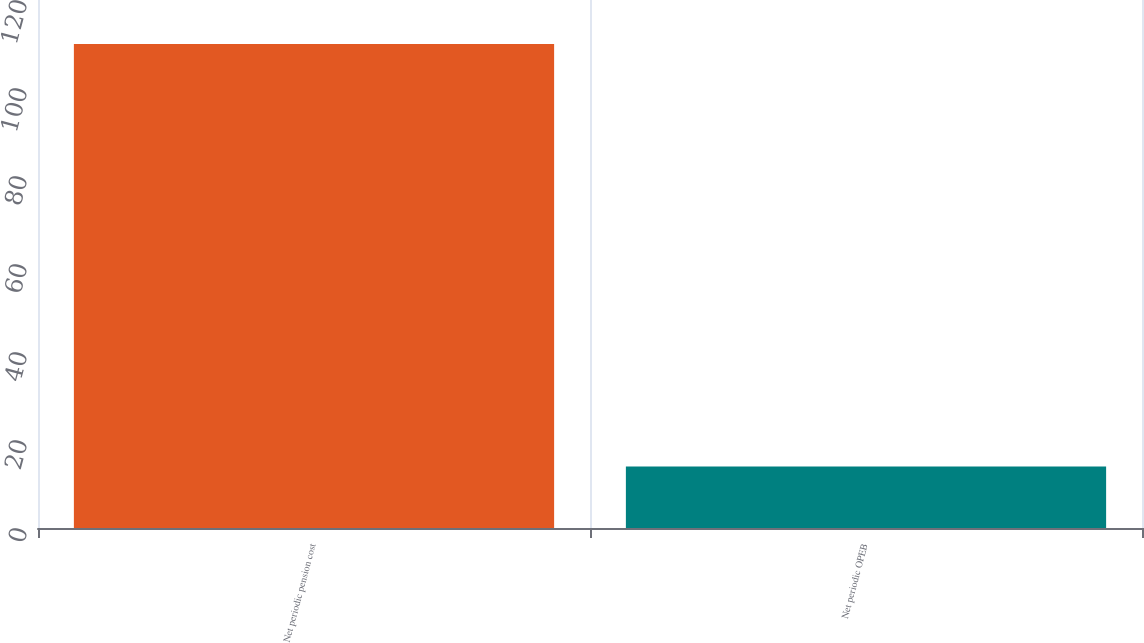<chart> <loc_0><loc_0><loc_500><loc_500><bar_chart><fcel>Net periodic pension cost<fcel>Net periodic OPEB<nl><fcel>110<fcel>14<nl></chart> 